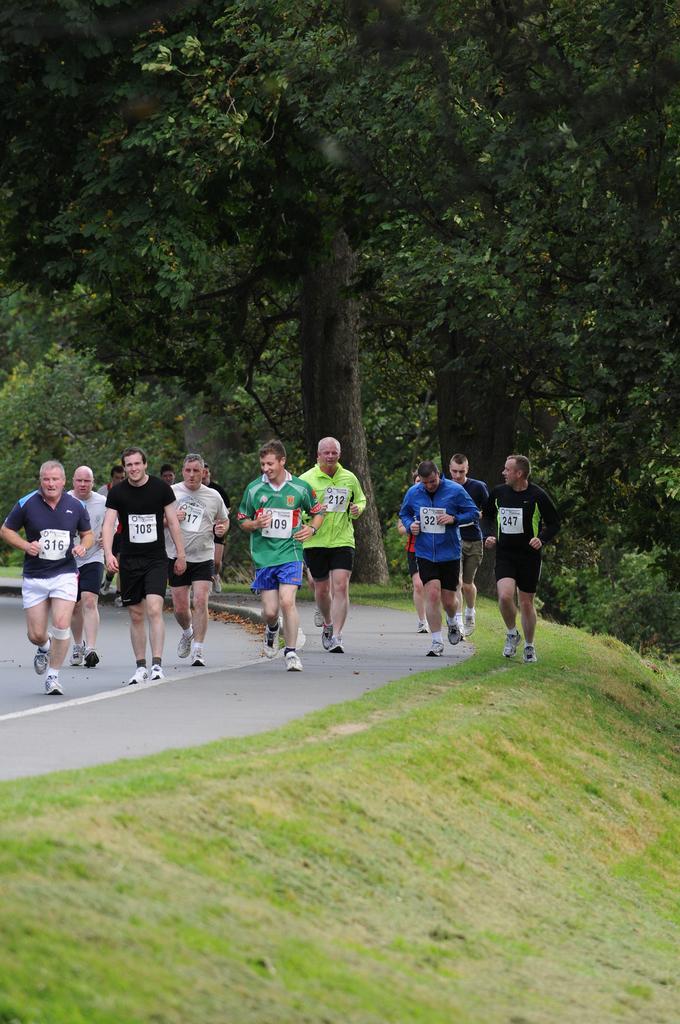Please provide a concise description of this image. There is a group of persons running on the ground as we can see in the middle of this image. There are trees in the background, and there is a grassy land at the bottom of this image. 